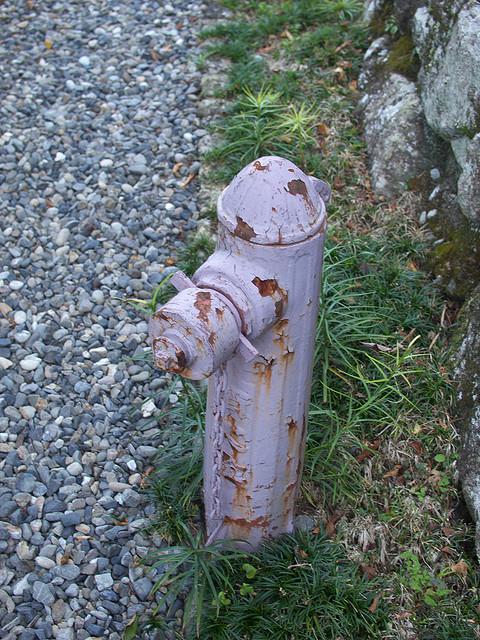What color is the hydrant?
Answer briefly. Gray. Is the hydrant in the gravel?
Answer briefly. No. How old is this pump?
Give a very brief answer. Old. 